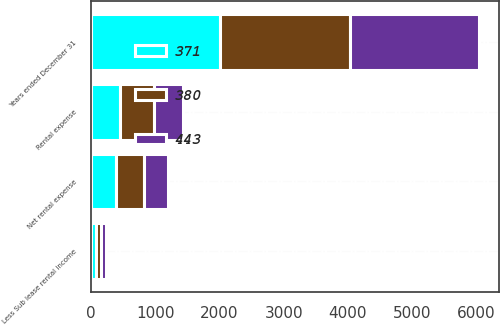Convert chart. <chart><loc_0><loc_0><loc_500><loc_500><stacked_bar_chart><ecel><fcel>Years ended December 31<fcel>Rental expense<fcel>Less Sub lease rental income<fcel>Net rental expense<nl><fcel>443<fcel>2015<fcel>454<fcel>83<fcel>371<nl><fcel>371<fcel>2014<fcel>455<fcel>75<fcel>380<nl><fcel>380<fcel>2013<fcel>520<fcel>77<fcel>443<nl></chart> 